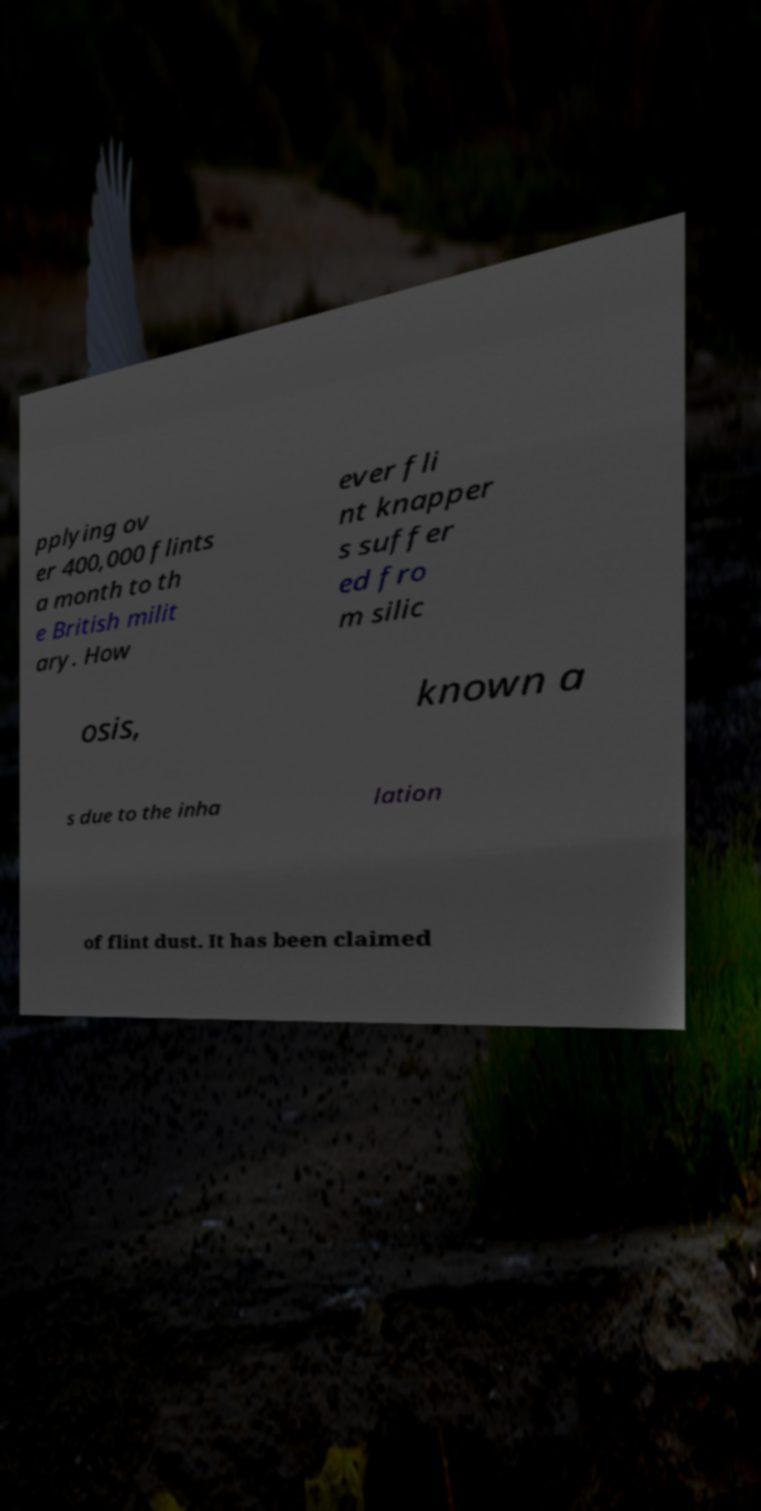There's text embedded in this image that I need extracted. Can you transcribe it verbatim? pplying ov er 400,000 flints a month to th e British milit ary. How ever fli nt knapper s suffer ed fro m silic osis, known a s due to the inha lation of flint dust. It has been claimed 